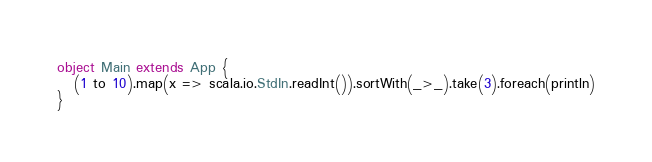Convert code to text. <code><loc_0><loc_0><loc_500><loc_500><_Scala_>object Main extends App {
   (1 to 10).map(x => scala.io.StdIn.readInt()).sortWith(_>_).take(3).foreach(println)
}
</code> 